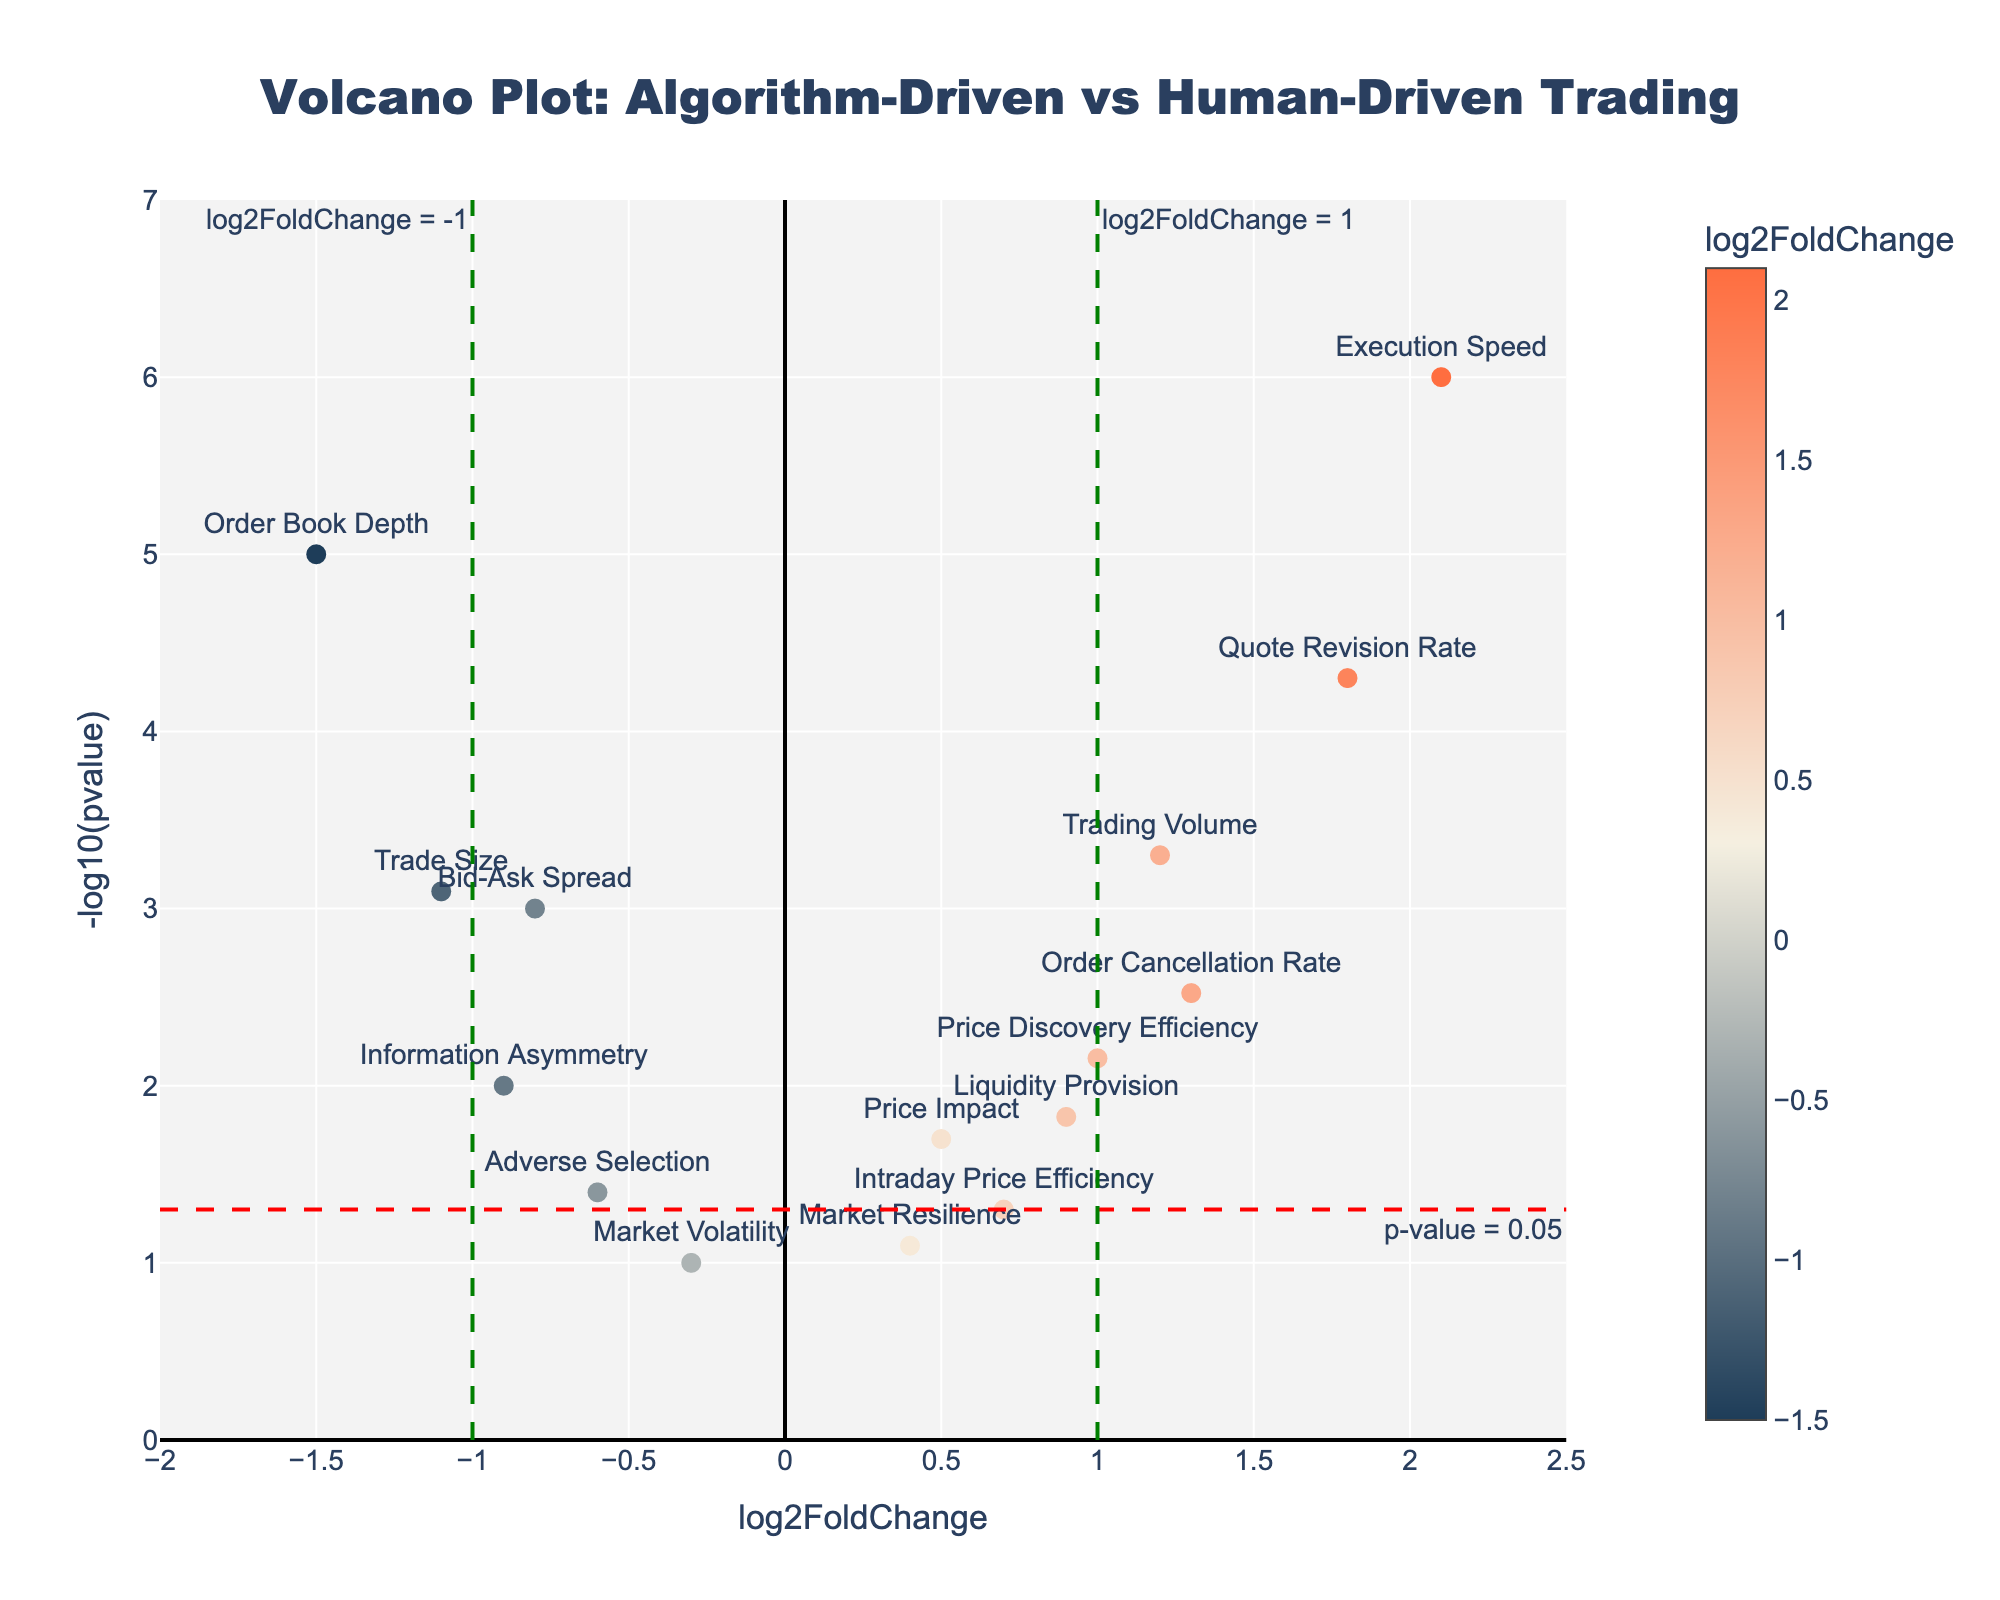What is the title of the plot? The title is located at the top of the figure and it's often styled distinctively to grab attention. It reads, "Volcano Plot: Algorithm-Driven vs Human-Driven Trading."
Answer: Volcano Plot: Algorithm-Driven vs Human-Driven Trading What do the x-axis and y-axis represent? The x-axis is labeled as "log2FoldChange," representing the log base 2 of fold change between algorithm-driven and human-driven trading sessions. The y-axis is labeled as "-log10(pvalue)," representing the negative log base 10 of p-values.
Answer: log2FoldChange and -log10(pvalue) How many data points are significantly different at a p-value threshold of 0.05? Look for points above the horizontal dashed red line, which marks the p-value threshold of 0.05. There are 10 points above this line.
Answer: 10 Which market microstructure characteristic shows the highest log2FoldChange? Among the data points, the one with the highest log2FoldChange value is identified by its position on the x-axis. The highest value here is for "Execution Speed" at 2.1.
Answer: Execution Speed Which characteristic has the smallest p-value, and what is its -log10(pvalue)? Look for the highest point on the y-axis, which corresponds to the smallest p-value. "Execution Speed" has the highest -log10(pvalue), which is approximately 6.
Answer: Execution Speed, 6 What is the log2FoldChange and p-value for Order Book Depth? Locate the data point labeled "Order Book Depth." Its x-axis value is -1.5, and its y-axis value corresponds to a -log10(pvalue) of 5, which translates to a p-value of about 0.00001.
Answer: -1.5 and 0.00001 Which characteristics have a negative log2FoldChange and are statistically significant? Look for points to the left of the green vertical line at -1 and above the red horizontal p-value threshold line. These characteristics are "Bid-Ask Spread," "Order Book Depth," "Trade Size," and "Information Asymmetry."
Answer: Bid-Ask Spread, Order Book Depth, Trade Size, Information Asymmetry Are there any characteristics with a log2FoldChange close to zero but highly significant? Check for points near the x-axis (log2FoldChange close to zero) but high on the y-axis (-log10(pvalue) high). There are none in this plot with these conditions.
Answer: No Which characteristic has nearly the lowest significance among those with a positive log2FoldChange? Identify the point with the lowest y-axis value among those to the right of the vertical line at 0 (positive log2FoldChange). "Intraday Price Efficiency" has a -log10(pvalue) of 1.3, which is the lowest among positive log2FoldChange values.
Answer: Intraday Price Efficiency How many characteristics have a -log10(pvalue) greater than 2 but a log2FoldChange between -1 and 1? Search for points above the y-axis value of 2 but between the vertical lines at -1 and 1. There are four such points: "Price Impact," "Liquidity Provision," "Adverse Selection," and "Market Resilience."
Answer: 4 